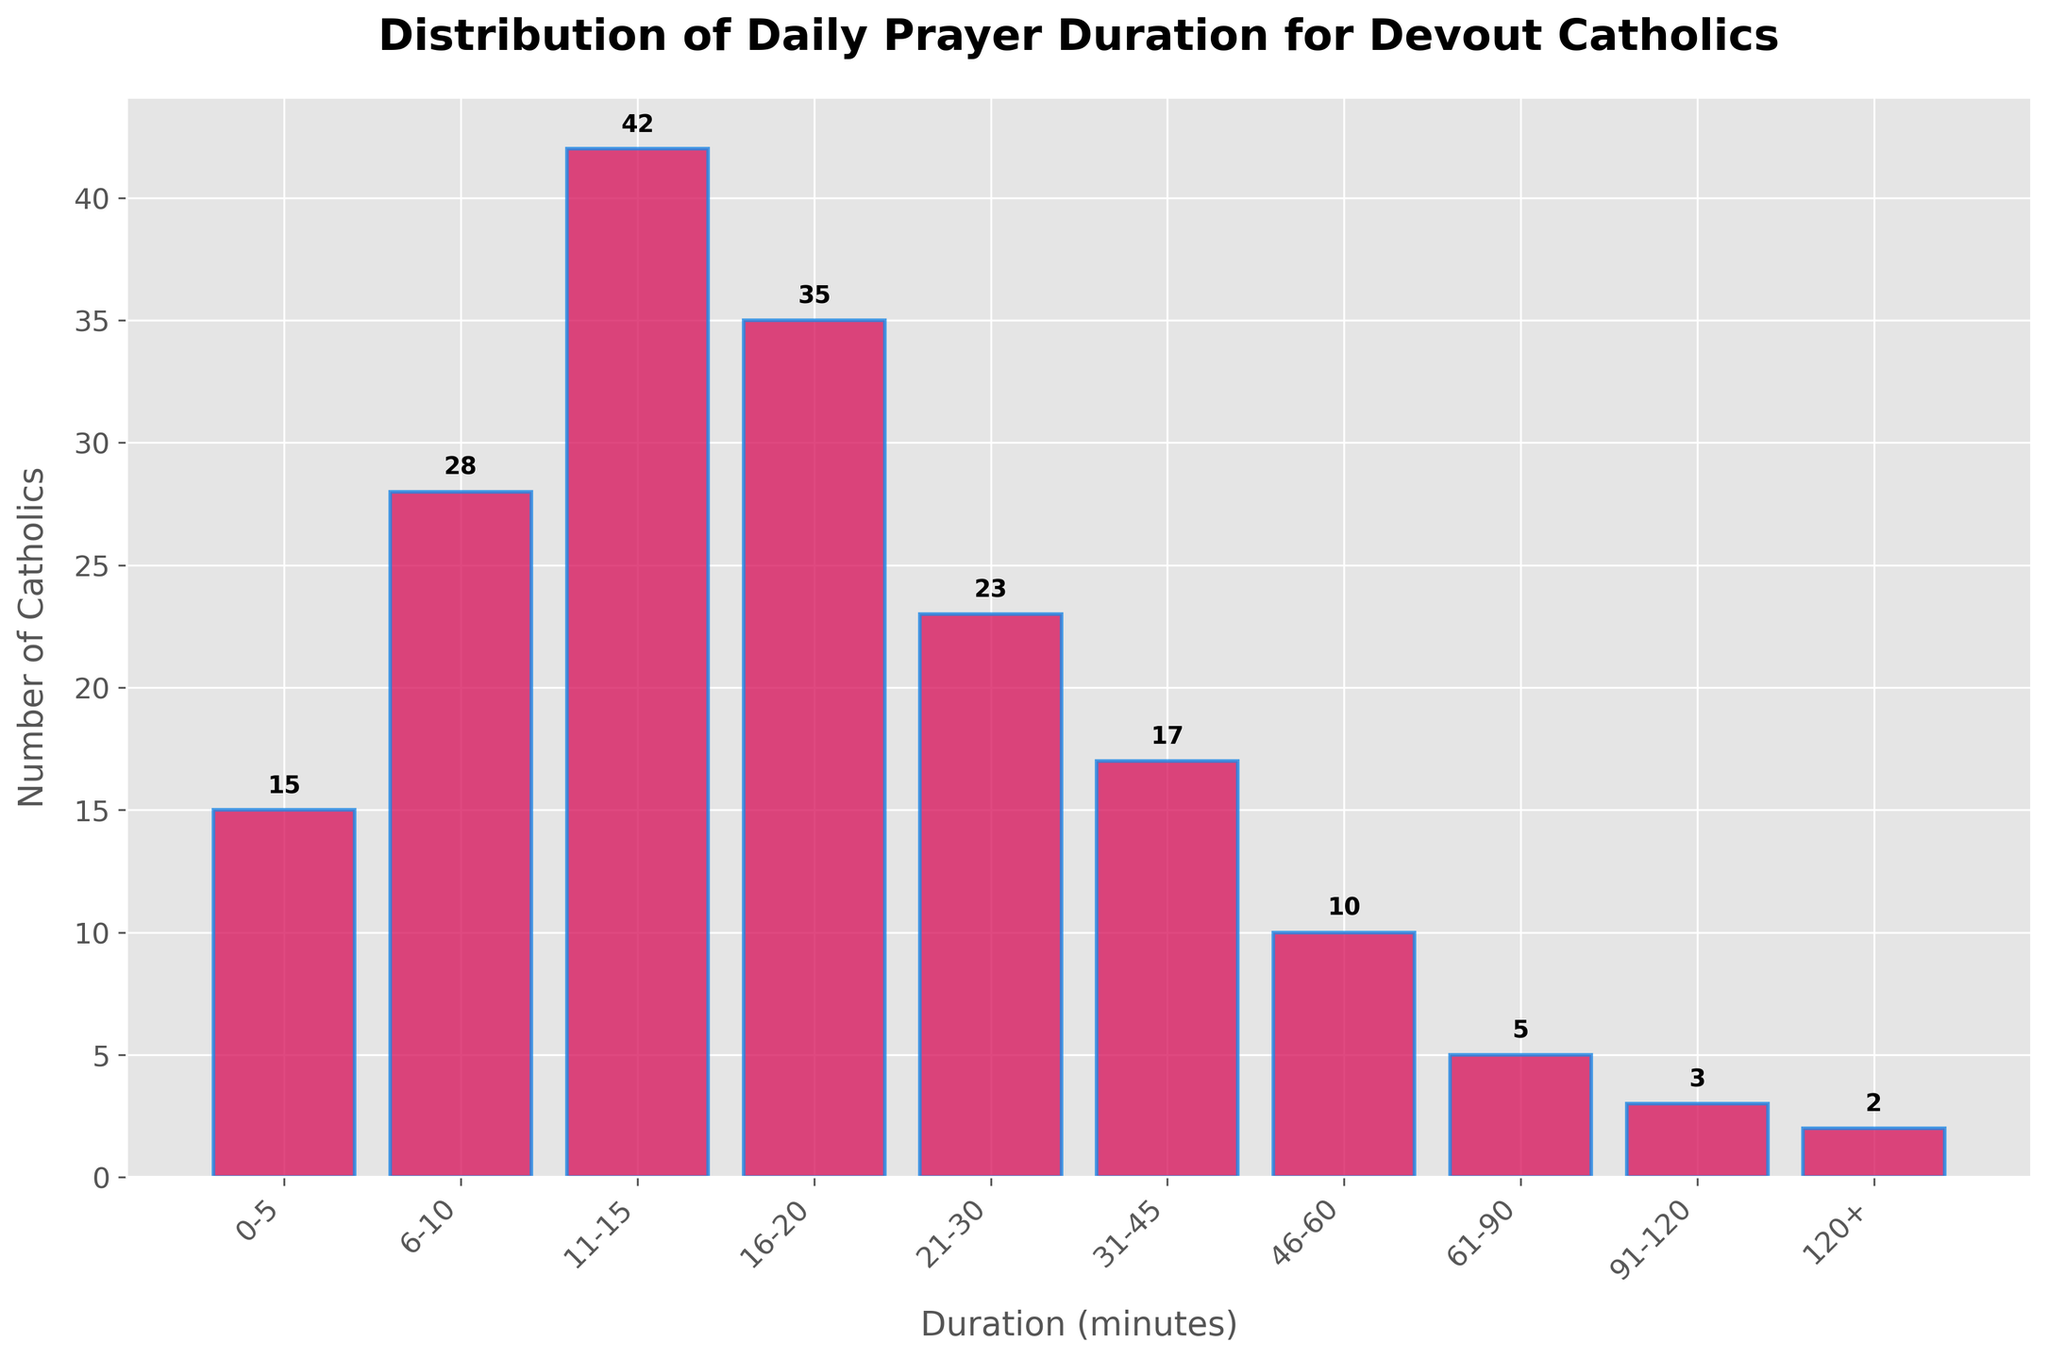What's the title of the plot? The title of the plot is prominently displayed at the top of the figure. It reads "Distribution of Daily Prayer Duration for Devout Catholics".
Answer: Distribution of Daily Prayer Duration for Devout Catholics What is the duration interval with the highest number of Catholics? The bar for the interval 11-15 minutes is the tallest, indicating it has the highest number of Catholics.
Answer: 11-15 How many Catholics spend between 46-60 minutes in daily prayer? Look for the bar labeled 46-60 minutes and read the value at the top of the bar. The corresponding number is 10.
Answer: 10 What is the total number of Catholics represented in the histogram? Sum the number of Catholics across all duration intervals: 15 + 28 + 42 + 35 + 23 + 17 + 10 + 5 + 3 + 2 = 180.
Answer: 180 Which two duration intervals have the same number of Catholics? Comparing the heights of the bars, the intervals 31-45 minutes and 0-5 minutes both have a height of 15.
Answer: 0-5 and 31-45 What is the combined number of Catholics who spend either 6-10 or 16-20 minutes in daily prayer? Add the number of Catholics in the 6-10 minutes interval (28) and the 16-20 minutes interval (35): 28 + 35 = 63.
Answer: 63 Which duration interval shows the least number of Catholics? The shortest bar corresponds to the interval 120+ minutes, indicating it has the least number of Catholics, which is 2.
Answer: 120+ Is the number of Catholics who pray for more than 60 minutes greater than those who pray for 21-30 minutes? Sum the number of Catholics for intervals >60 minutes: (5 + 3 + 2 = 10). Compare this with the number in the 21-30 minutes interval (23). 10 is not greater than 23.
Answer: No What is the average number of Catholics per interval? Sum the total number of Catholics (180) and divide by the total number of intervals (10): 180 / 10 = 18.
Answer: 18 How many more Catholics spend 11-15 minutes in daily prayer compared to those who spend 61-90 minutes? Subtract the number of Catholics in the 61-90 minutes interval (5) from the 11-15 minutes interval (42): 42 - 5 = 37.
Answer: 37 